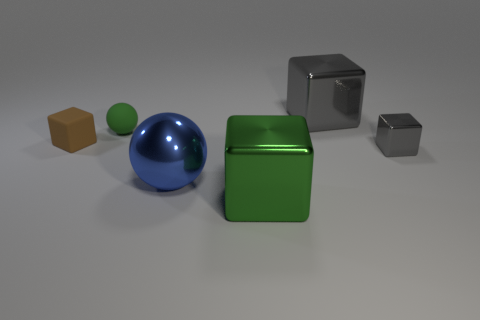Add 3 tiny brown things. How many objects exist? 9 Subtract all cubes. How many objects are left? 2 Subtract 0 purple blocks. How many objects are left? 6 Subtract all small matte spheres. Subtract all small matte spheres. How many objects are left? 4 Add 5 large things. How many large things are left? 8 Add 3 metal cubes. How many metal cubes exist? 6 